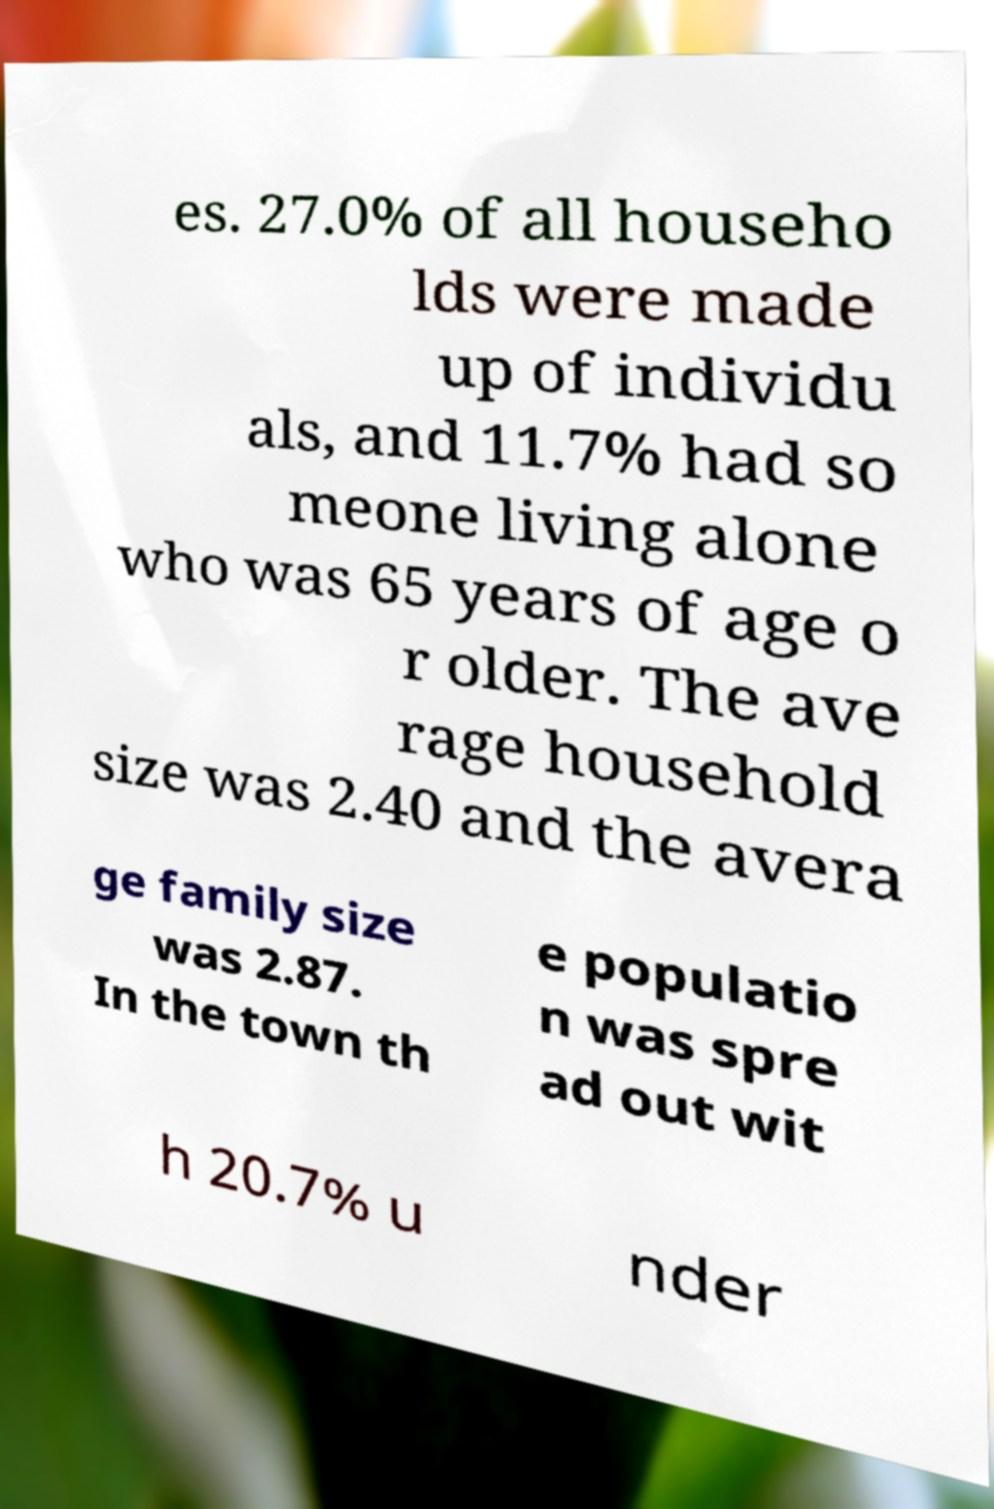Can you read and provide the text displayed in the image?This photo seems to have some interesting text. Can you extract and type it out for me? es. 27.0% of all househo lds were made up of individu als, and 11.7% had so meone living alone who was 65 years of age o r older. The ave rage household size was 2.40 and the avera ge family size was 2.87. In the town th e populatio n was spre ad out wit h 20.7% u nder 